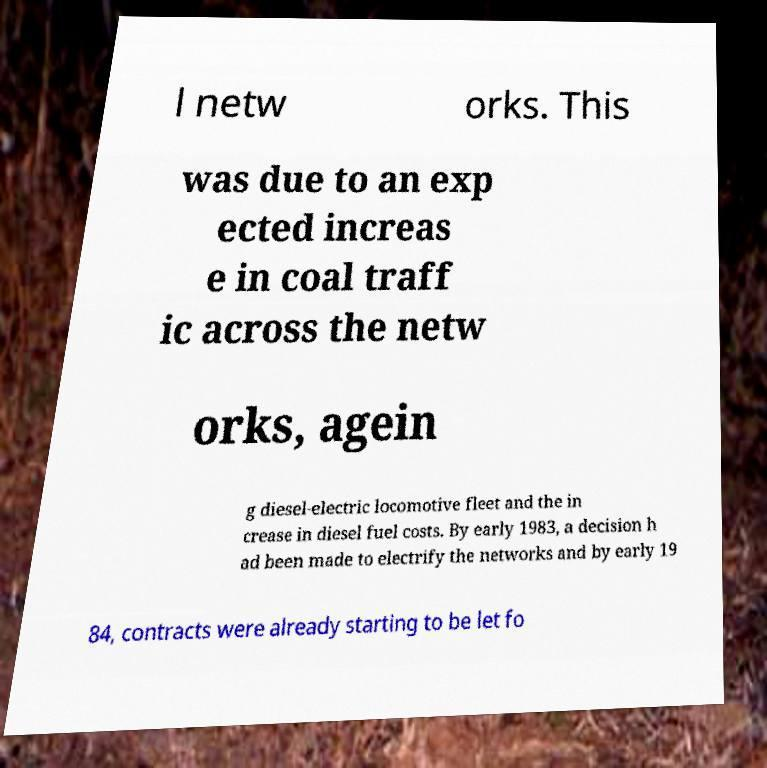Can you read and provide the text displayed in the image?This photo seems to have some interesting text. Can you extract and type it out for me? l netw orks. This was due to an exp ected increas e in coal traff ic across the netw orks, agein g diesel-electric locomotive fleet and the in crease in diesel fuel costs. By early 1983, a decision h ad been made to electrify the networks and by early 19 84, contracts were already starting to be let fo 